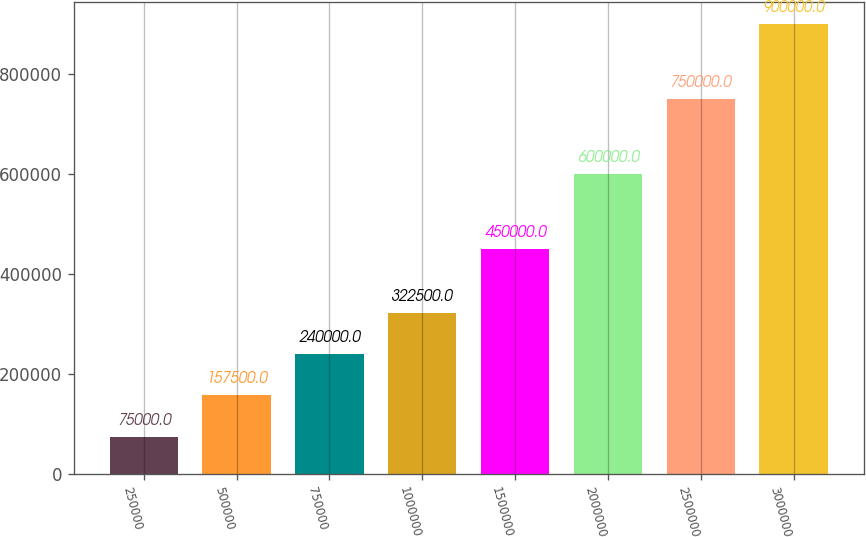<chart> <loc_0><loc_0><loc_500><loc_500><bar_chart><fcel>250000<fcel>500000<fcel>750000<fcel>1000000<fcel>1500000<fcel>2000000<fcel>2500000<fcel>3000000<nl><fcel>75000<fcel>157500<fcel>240000<fcel>322500<fcel>450000<fcel>600000<fcel>750000<fcel>900000<nl></chart> 